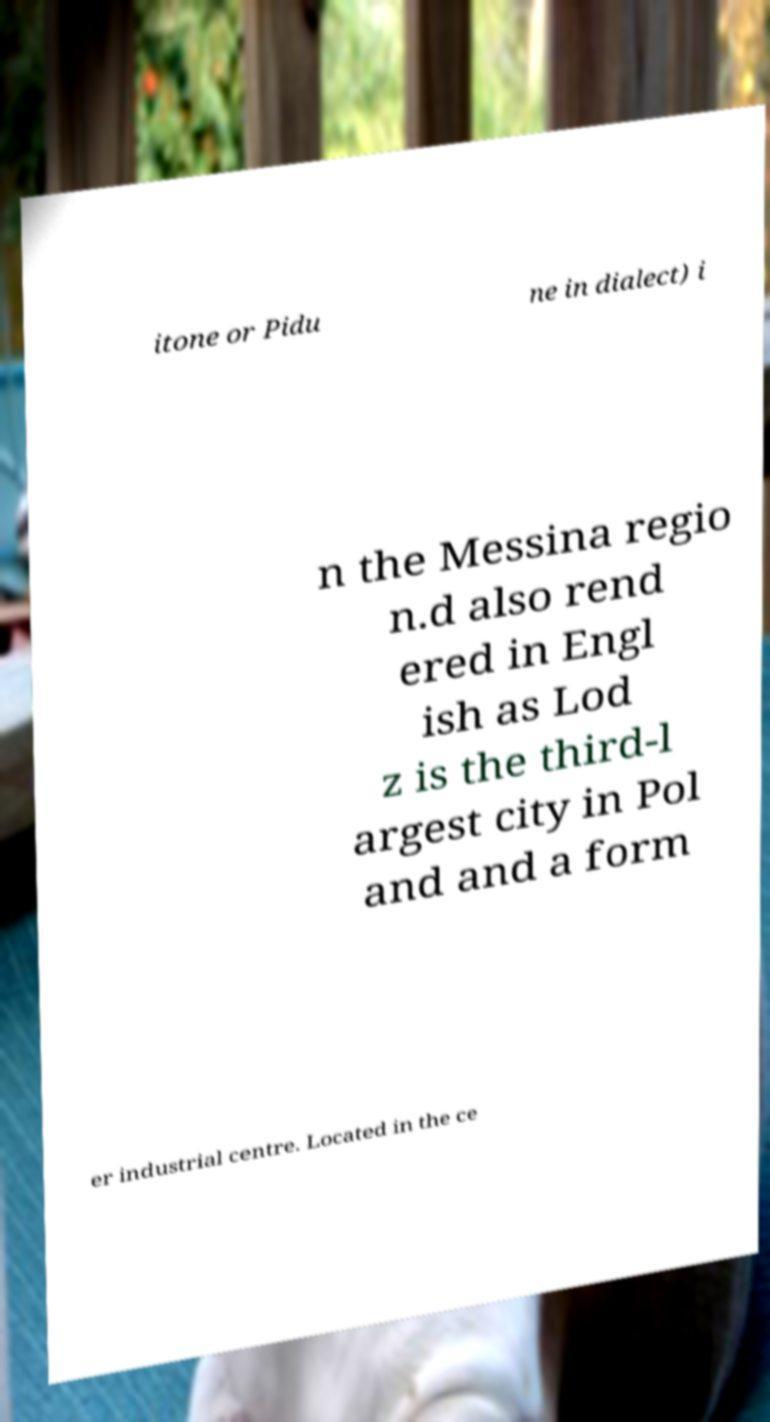There's text embedded in this image that I need extracted. Can you transcribe it verbatim? itone or Pidu ne in dialect) i n the Messina regio n.d also rend ered in Engl ish as Lod z is the third-l argest city in Pol and and a form er industrial centre. Located in the ce 